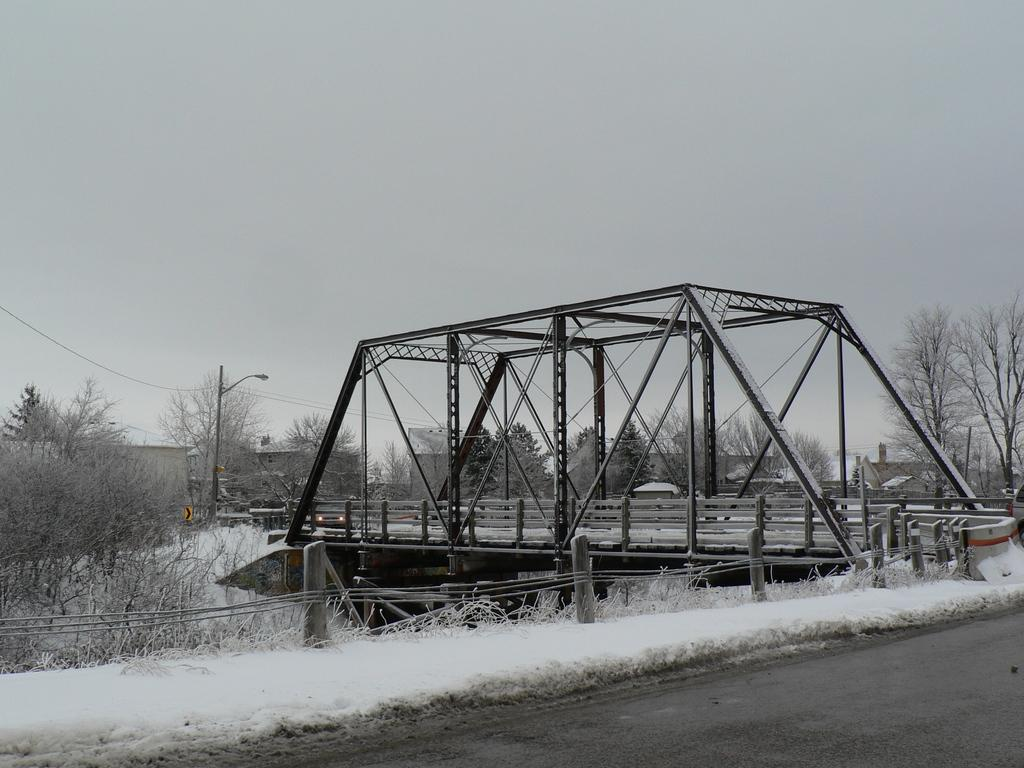What type of structure can be seen in the image? There is a bridge in the image. What natural elements are present in the image? There are many trees in the image. Are there any man-made structures besides the bridge? Yes, there are few houses in the image. What is at the bottom of the image? There is a road at the bottom of the image. What force is causing the stomach to shake in the image? There is no stomach or force causing it to shake in the image; the image features a bridge, trees, houses, and a road. 